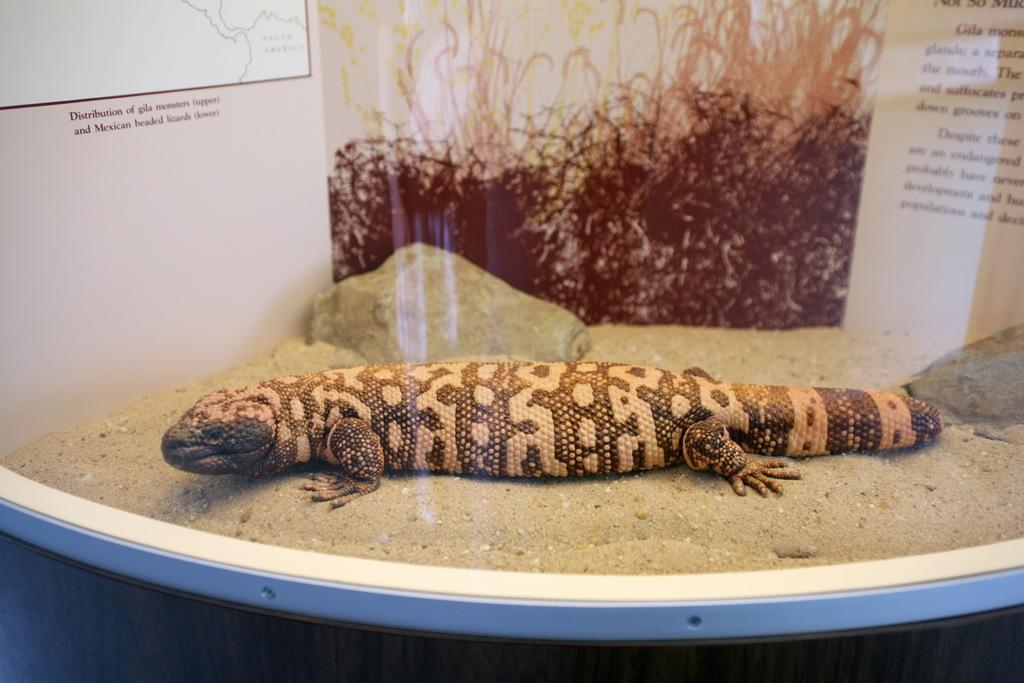What type of animal is in the image? There is a Gila monster in the image. What is the Gila monster standing on? The Gila monster is on sand. How is the sand presented in the image? The sand is placed in a shell. What type of health advice can be seen in the image? There is no health advice present in the image; it features a Gila monster on sand in a shell. 